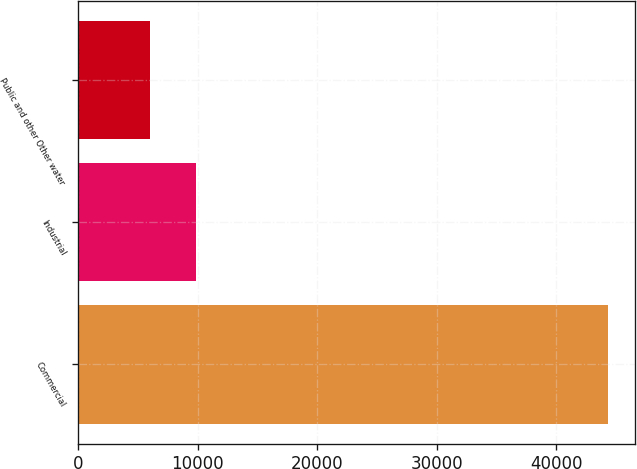<chart> <loc_0><loc_0><loc_500><loc_500><bar_chart><fcel>Commercial<fcel>Industrial<fcel>Public and other Other water<nl><fcel>44349<fcel>9834<fcel>5999<nl></chart> 